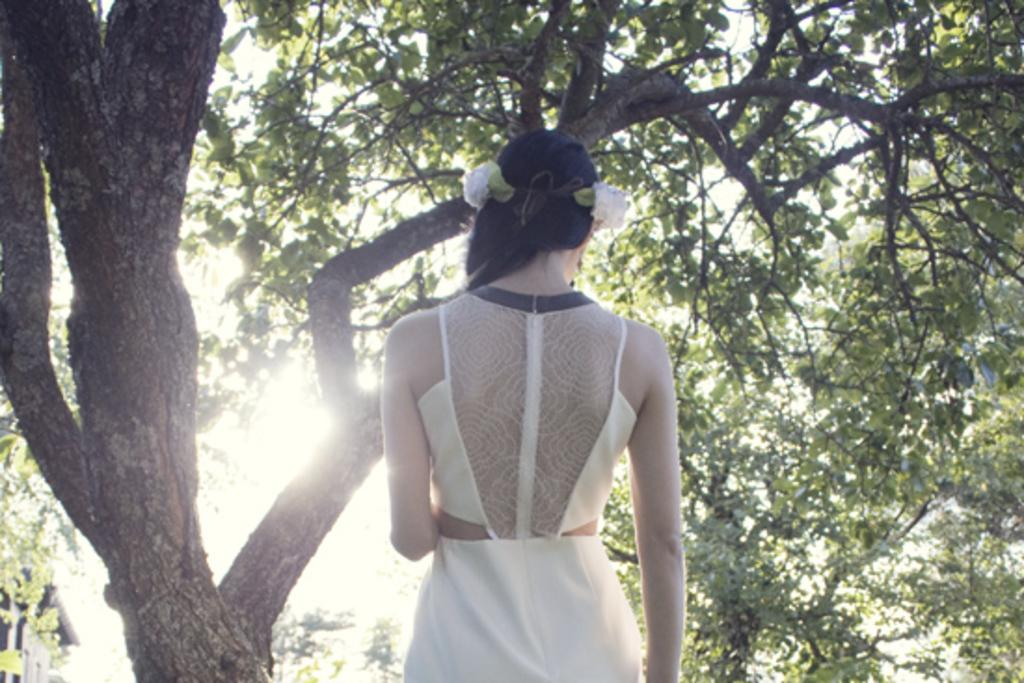What is the main subject of the image? There is a woman standing in the image. Can you describe the background of the image? There is a tree in the background of the image. What type of wool is being used to develop the appliance in the image? There is no wool or appliance present in the image; it features a woman standing with a tree in the background. 